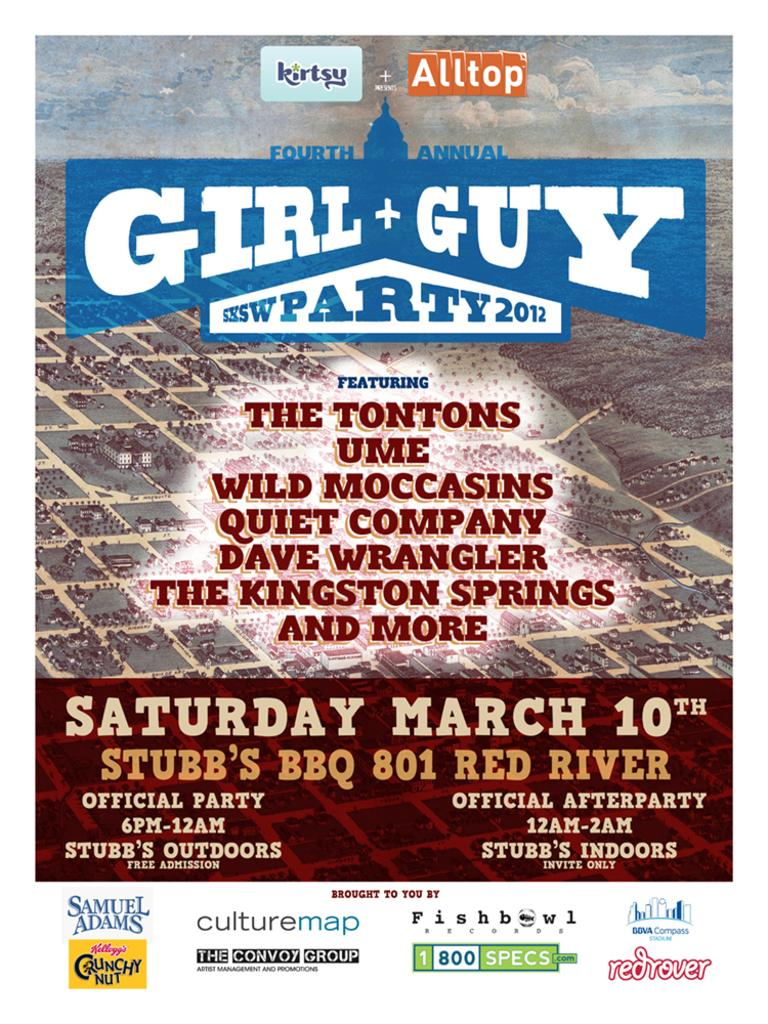<image>
Write a terse but informative summary of the picture. A poster advertising the Fourth Annual Girl + Guy SXSW Party 2012 